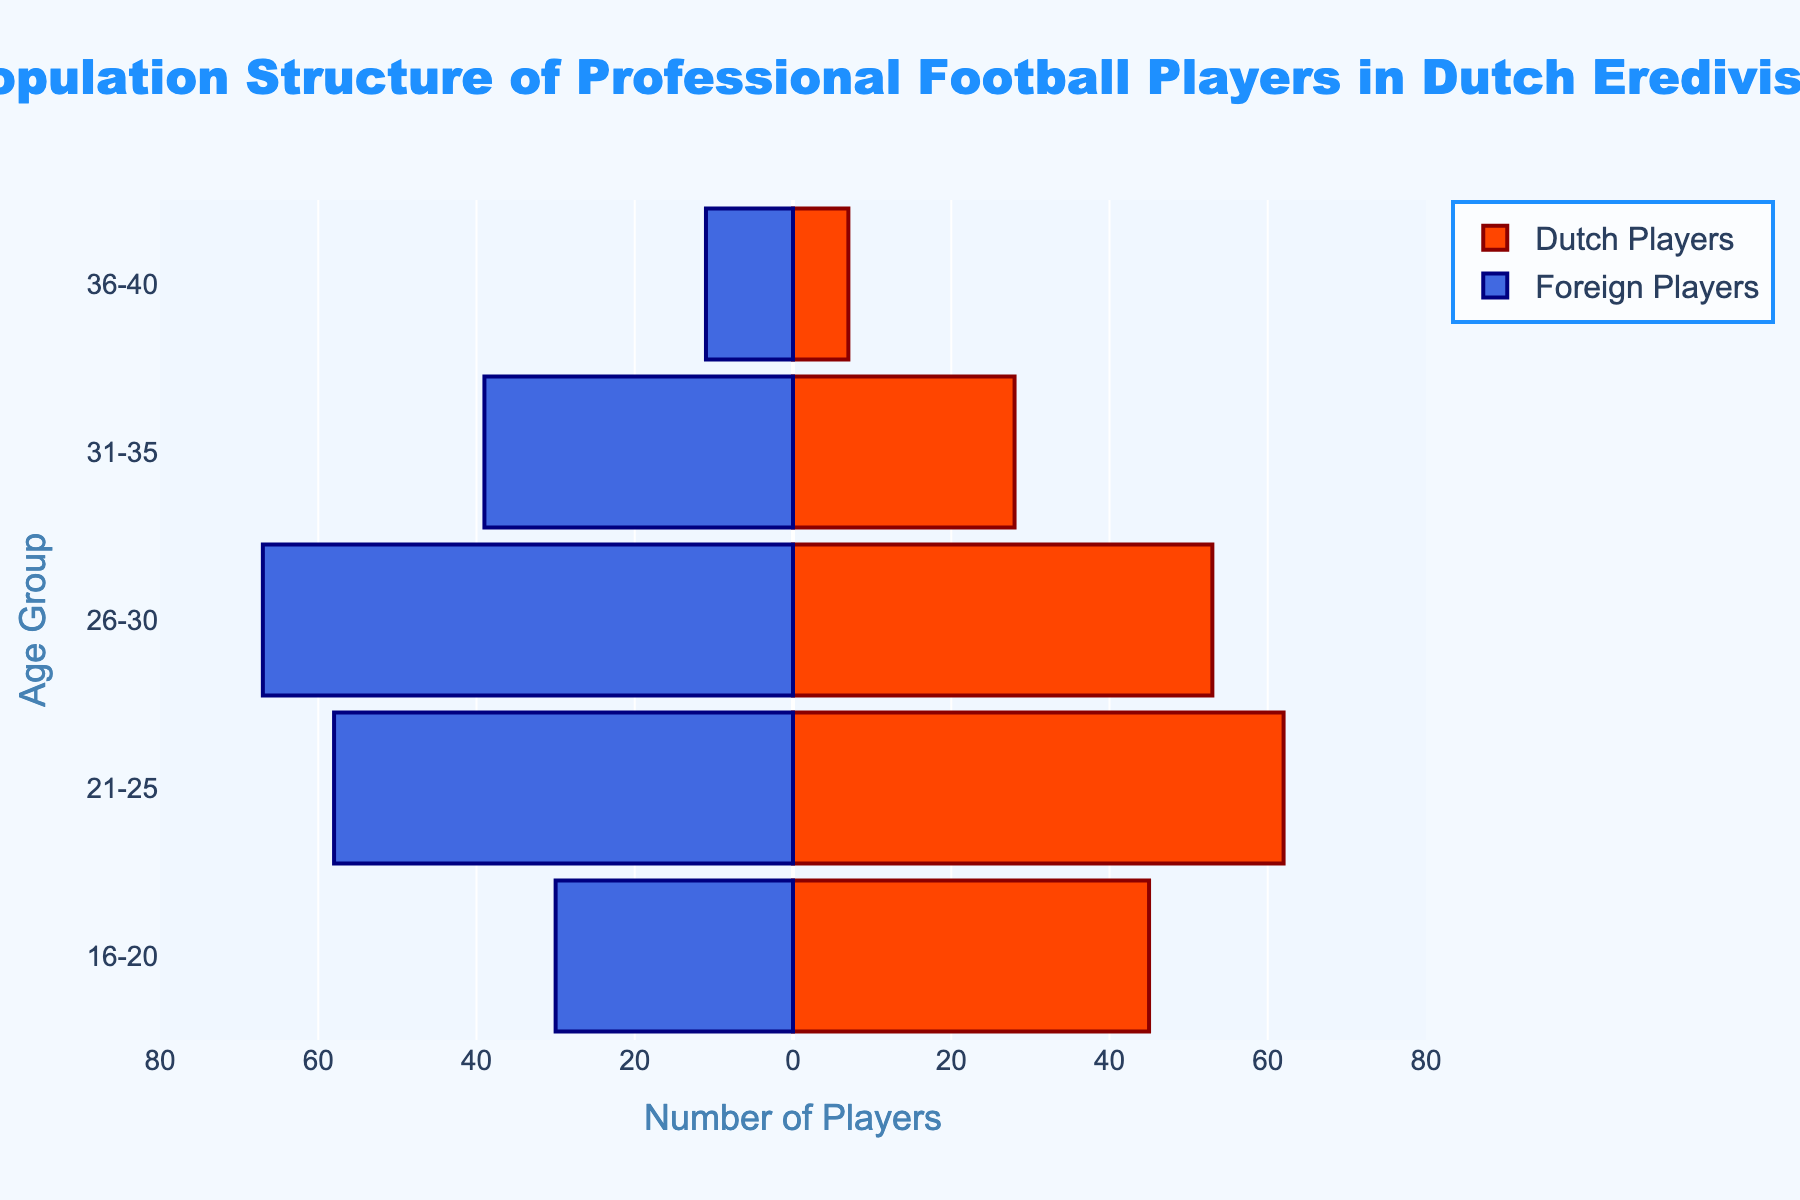What's the title of the plot? The title is displayed at the top of the plot in large, bold font.
Answer: Population Structure of Professional Football Players in Dutch Eredivisie Which age group has the highest number of Dutch players? The highest bar on the Dutch Players side corresponds to the age group 21-25.
Answer: 21-25 How many foreign players are there in the 31-35 age group? The length of the bar for the 31-35 age group on the Foreign Players side is 39.
Answer: 39 What's the total number of players in the 16-20 age group? Add the Dutch players (45) and foreign players (30) in the 16-20 age group.
Answer: 75 Are there more Dutch players or foreign players in the 26-30 age group? Compare the lengths of the bars for the 26-30 age group: Dutch Players (53) versus Foreign Players (67).
Answer: Foreign players How does the number of Dutch players in the 36-40 age group compare to that of foreign players in the same group? Compare the bar lengths for the 36-40 age group: 7 for Dutch players and 11 for foreign players.
Answer: Fewer Dutch players Which age group has the smallest difference between Dutch and foreign players? Calculate the differences for each age group and find the smallest one: 16-20 (15), 21-25 (4), 26-30 (14), 31-35 (11), 36-40 (4).
Answer: 21-25 and 36-40 What is the total number of foreign players across all age groups? Sum the foreign players in each age group: 30 + 58 + 67 + 39 + 11.
Answer: 205 What's the average number of Dutch players per age group? Sum the Dutch players across all age groups and divide by the number of age groups: (45 + 62 + 53 + 28 + 7) / 5.
Answer: 39 How many more foreign players are there than Dutch players in the 26-30 age group? Subtract the number of Dutch players from the number of foreign players in the 26-30 age group: 67 - 53.
Answer: 14 